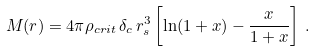<formula> <loc_0><loc_0><loc_500><loc_500>M ( r ) = 4 \pi \rho _ { c r i t } \, \delta _ { c } \, r _ { s } ^ { 3 } \left [ \ln ( 1 + x ) - \frac { x } { 1 + x } \right ] \, .</formula> 